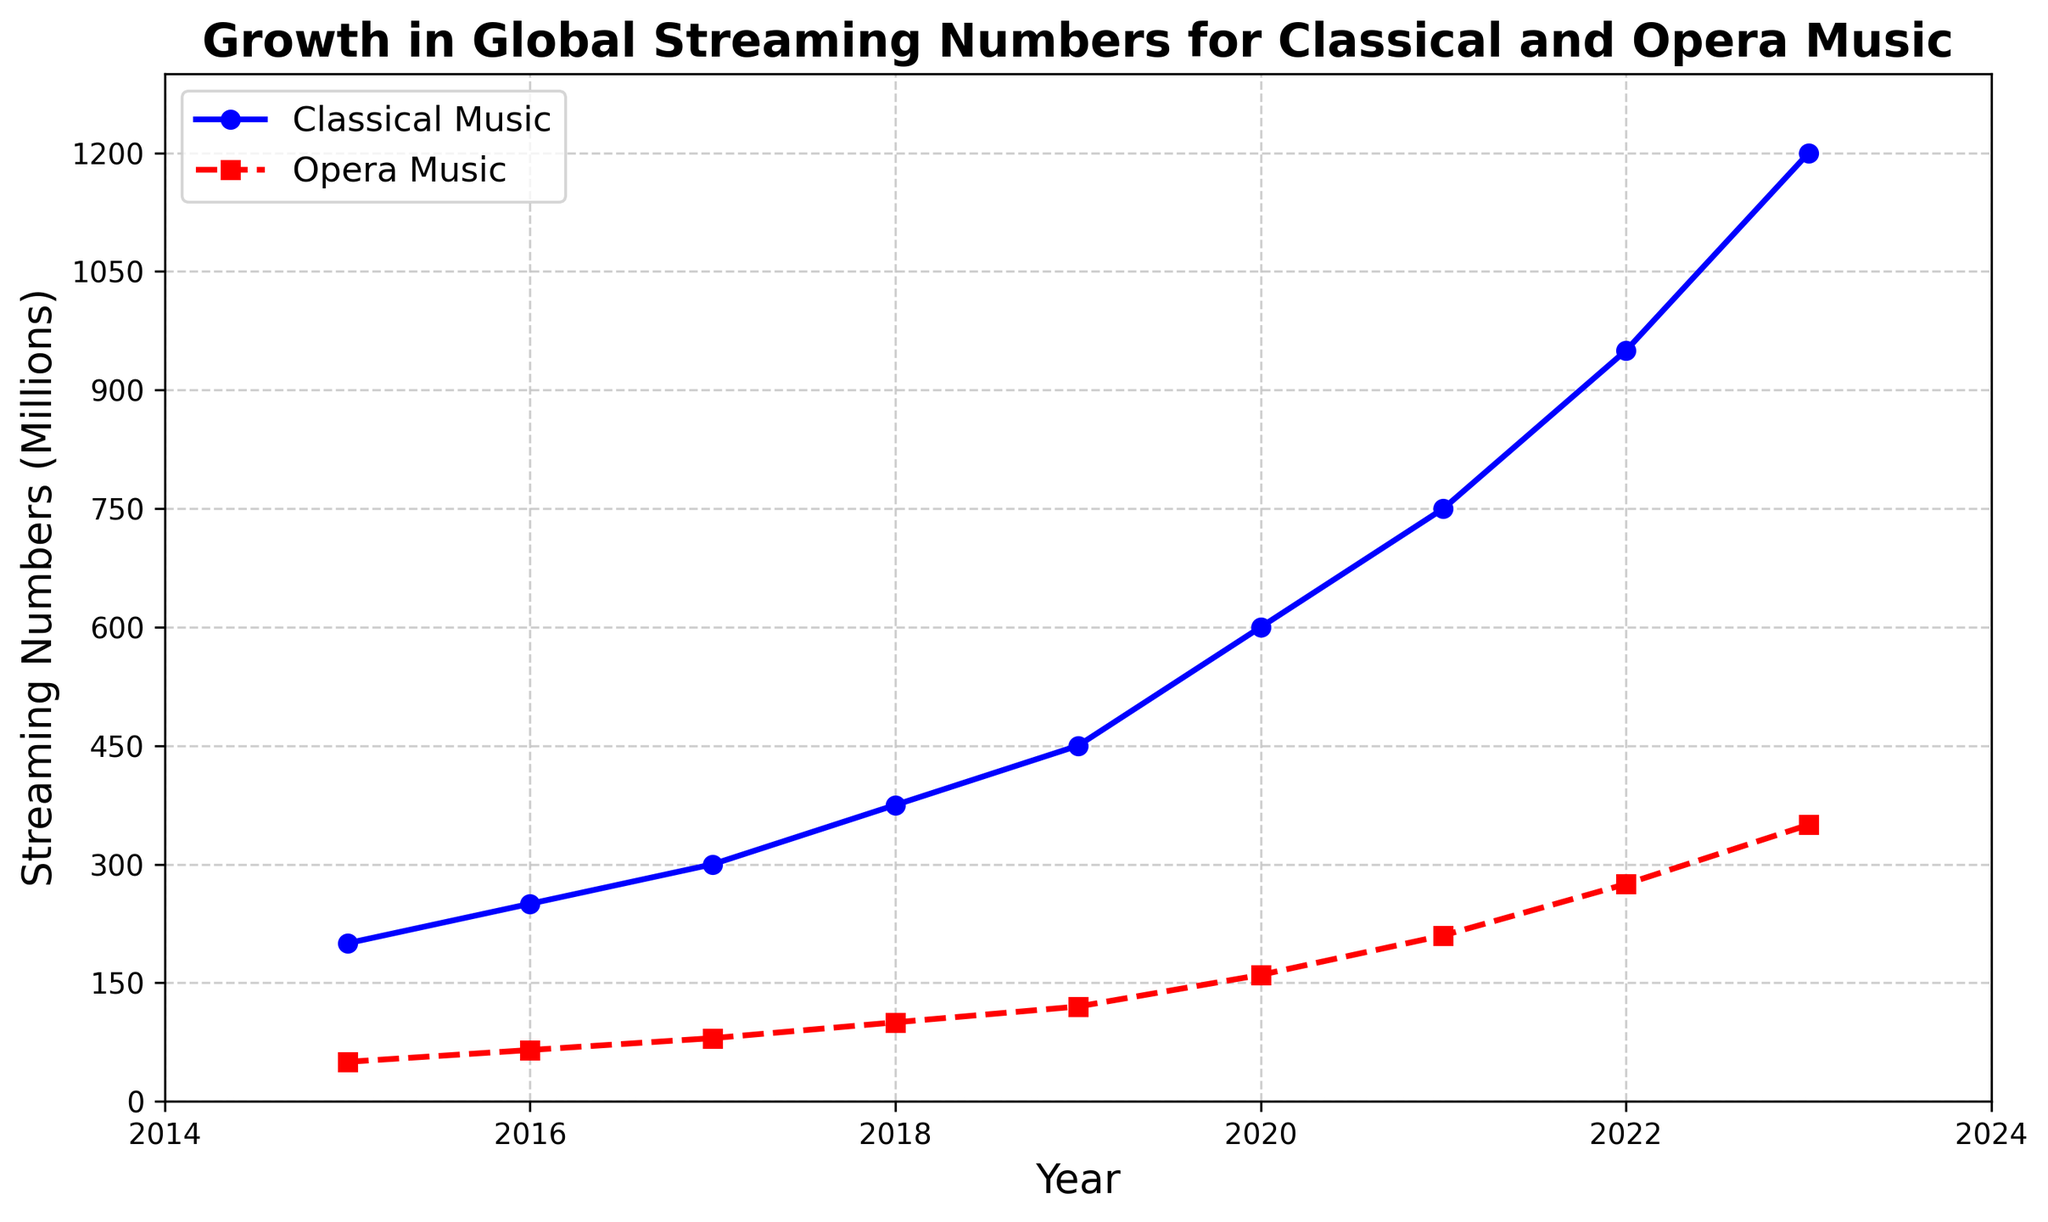What's the difference in streaming numbers between Classical Music and Opera Music in 2023? In 2023, the classical streaming number is 1200 million, and the opera streaming number is 350 million. The difference is calculated as 1200 - 350.
Answer: 850 million What's the average annual growth in streaming numbers for Classical Music between 2019 and 2023? The streaming numbers for Classical Music in 2019 and 2023 are 450 million and 1200 million, respectively. The average annual growth is calculated by dividing the difference (1200 - 450) by the number of years (2023-2019 = 4). Hence, the average annual growth is (1200 - 450) / 4.
Answer: 187.5 million Which genre experienced the higher growth from 2016 to 2022? For Classical Music, the growth from 2016 (250 million) to 2022 (950 million) is 950 - 250 = 700 million. For Opera Music, the growth from 2016 (65 million) to 2022 (275 million) is 275 - 65 = 210 million. Comparing these numbers, Classical Music experienced higher growth.
Answer: Classical Music In which year did both Classical and Opera Music experience the steepest increase in streaming numbers? By visually inspecting the figure, the steepest increases for both genres occur from 2019 to 2020. For Classical Music, the increase is from 450 million to 600 million. For Opera Music, the increase is from 120 million to 160 million.
Answer: 2019-2020 During what period did Opera Music surpass 200 million in streaming numbers? Inspecting the figure, Opera Music crosses the 200 million mark in 2021, continuing to rise afterward.
Answer: 2021 What is the combined number of Classical and Opera music streamings in 2017? In 2017, the streaming numbers for Classical and Opera Music are 300 million and 80 million, respectively. The combined number is calculated by summing these values: 300 + 80.
Answer: 380 million From 2015 to 2016, how much more did Classical Music grow compared to Opera Music? The growth for Classical Music from 2015 to 2016 is 250 - 200 = 50 million. For Opera Music, the growth in the same period is 65 - 50 = 15 million. Comparing these, Classical Music grew more by 50 - 15.
Answer: 35 million In which year did the streaming numbers for Classical Music first exceed 700 million? By looking at the figure, Classical Music first exceeds 700 million in 2021.
Answer: 2021 What is the growth rate of Opera Music streamings between 2018 and 2019? The streaming numbers for Opera Music are 100 million in 2018 and 120 million in 2019. The growth rate is calculated as ((120 - 100) / 100) * 100%. Hence, the growth rate is (20 / 100) * 100%.
Answer: 20% Comparing the year 2020 to 2015, by how much did Opera Music's streaming numbers increase? In 2020, Opera Music streaming numbers are 160 million, and in 2015, they are 50 million. The increase is calculated as 160 - 50.
Answer: 110 million 